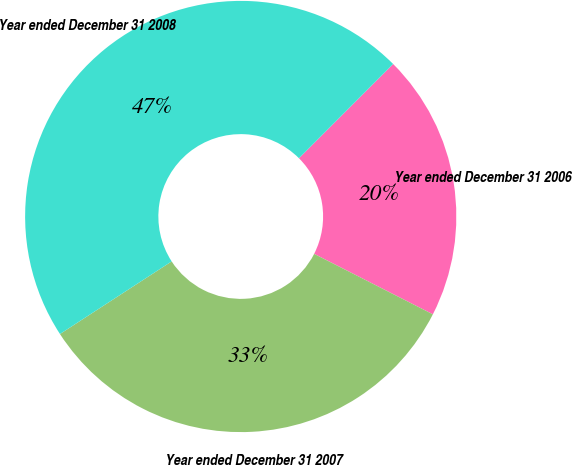Convert chart. <chart><loc_0><loc_0><loc_500><loc_500><pie_chart><fcel>Year ended December 31 2006<fcel>Year ended December 31 2007<fcel>Year ended December 31 2008<nl><fcel>20.0%<fcel>33.33%<fcel>46.67%<nl></chart> 